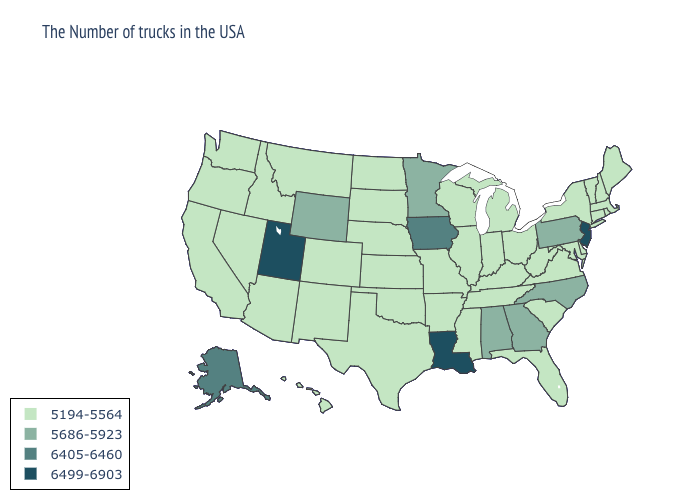Which states have the lowest value in the Northeast?
Keep it brief. Maine, Massachusetts, Rhode Island, New Hampshire, Vermont, Connecticut, New York. Does North Carolina have the same value as California?
Quick response, please. No. Name the states that have a value in the range 6405-6460?
Be succinct. Iowa, Alaska. Does Alaska have the lowest value in the West?
Short answer required. No. What is the value of Massachusetts?
Keep it brief. 5194-5564. What is the highest value in the USA?
Give a very brief answer. 6499-6903. Name the states that have a value in the range 6405-6460?
Give a very brief answer. Iowa, Alaska. What is the value of Florida?
Be succinct. 5194-5564. What is the value of Oregon?
Keep it brief. 5194-5564. Name the states that have a value in the range 5686-5923?
Short answer required. Pennsylvania, North Carolina, Georgia, Alabama, Minnesota, Wyoming. Name the states that have a value in the range 5194-5564?
Keep it brief. Maine, Massachusetts, Rhode Island, New Hampshire, Vermont, Connecticut, New York, Delaware, Maryland, Virginia, South Carolina, West Virginia, Ohio, Florida, Michigan, Kentucky, Indiana, Tennessee, Wisconsin, Illinois, Mississippi, Missouri, Arkansas, Kansas, Nebraska, Oklahoma, Texas, South Dakota, North Dakota, Colorado, New Mexico, Montana, Arizona, Idaho, Nevada, California, Washington, Oregon, Hawaii. Name the states that have a value in the range 6405-6460?
Keep it brief. Iowa, Alaska. Name the states that have a value in the range 5686-5923?
Answer briefly. Pennsylvania, North Carolina, Georgia, Alabama, Minnesota, Wyoming. What is the lowest value in the USA?
Concise answer only. 5194-5564. 